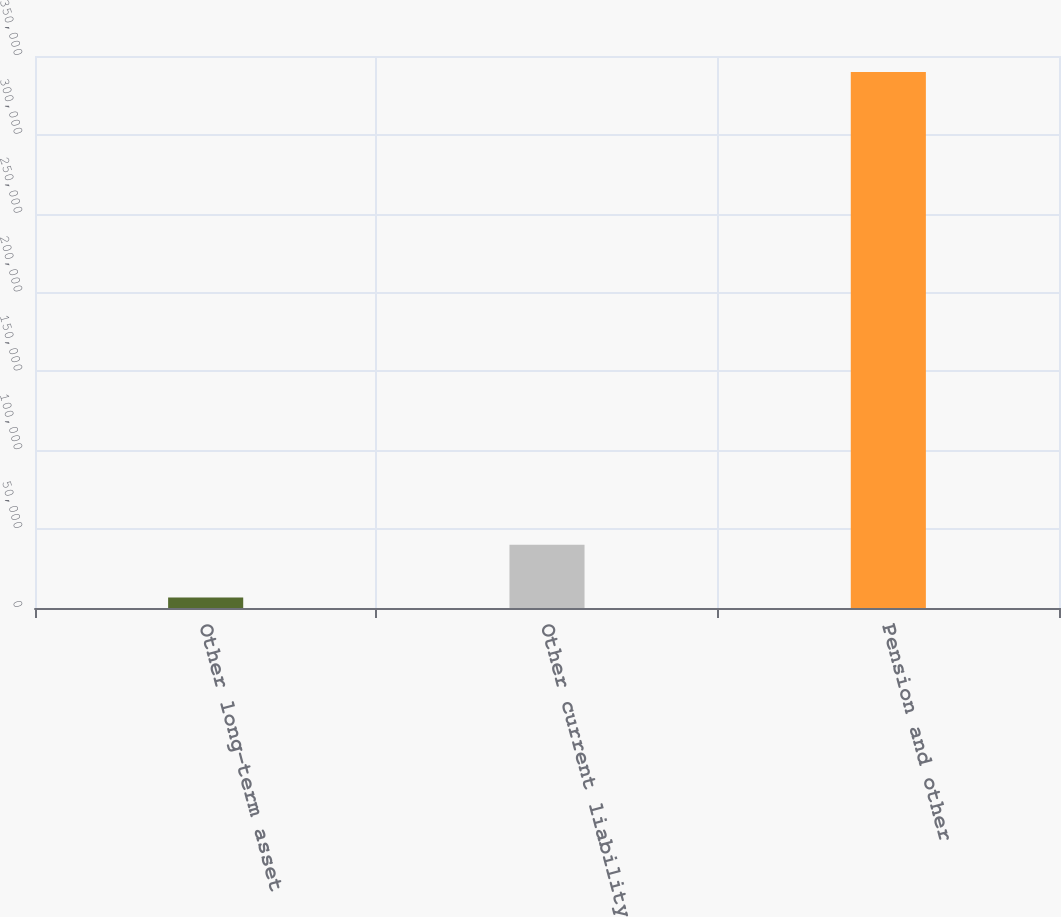Convert chart. <chart><loc_0><loc_0><loc_500><loc_500><bar_chart><fcel>Other long-term asset<fcel>Other current liability<fcel>Pension and other<nl><fcel>6721<fcel>40036.1<fcel>339872<nl></chart> 